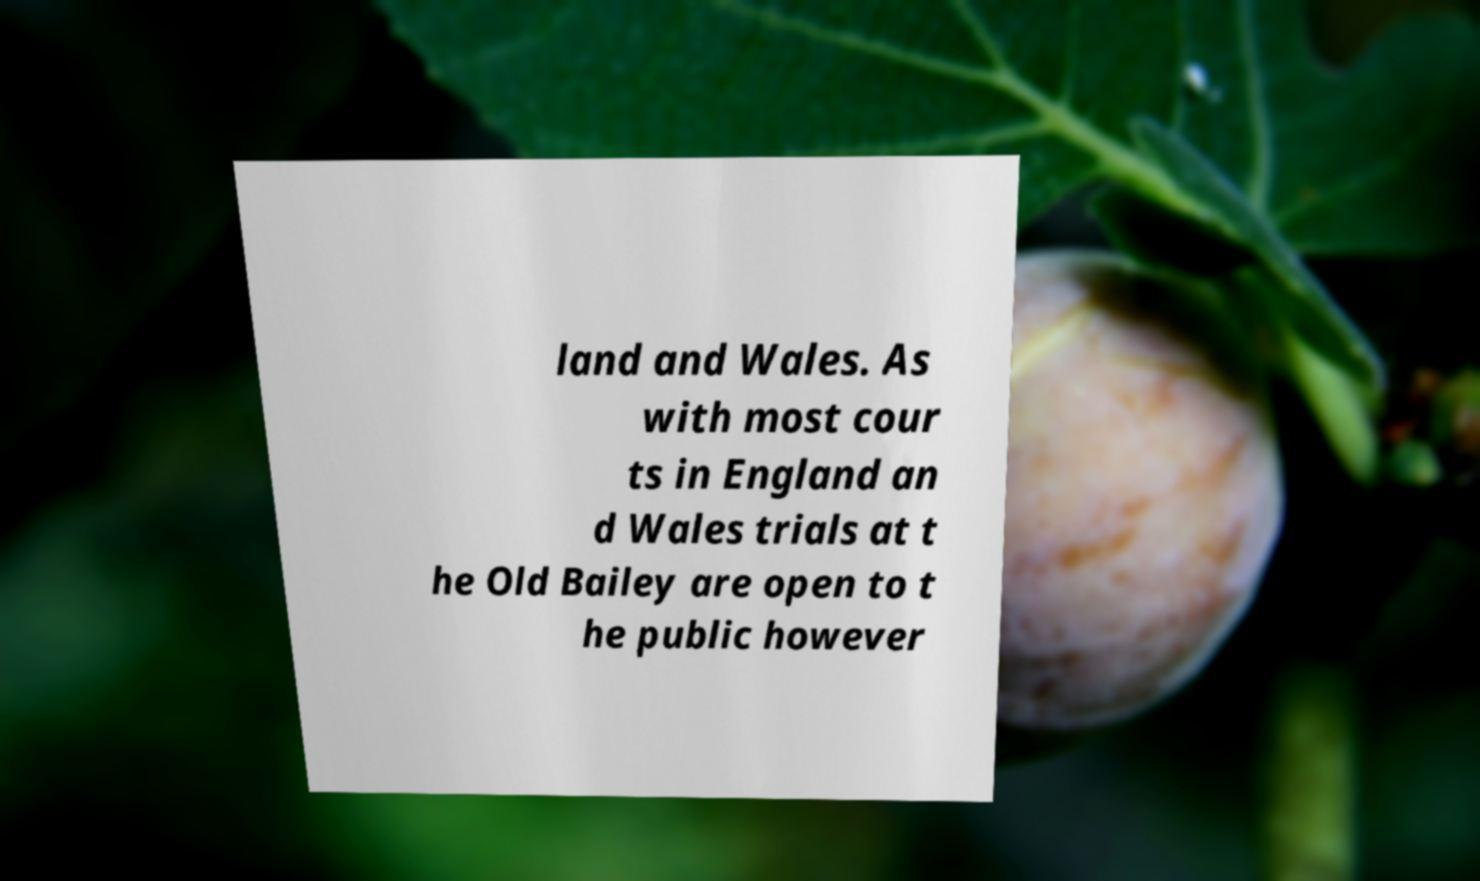Could you extract and type out the text from this image? land and Wales. As with most cour ts in England an d Wales trials at t he Old Bailey are open to t he public however 